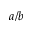<formula> <loc_0><loc_0><loc_500><loc_500>a / b</formula> 